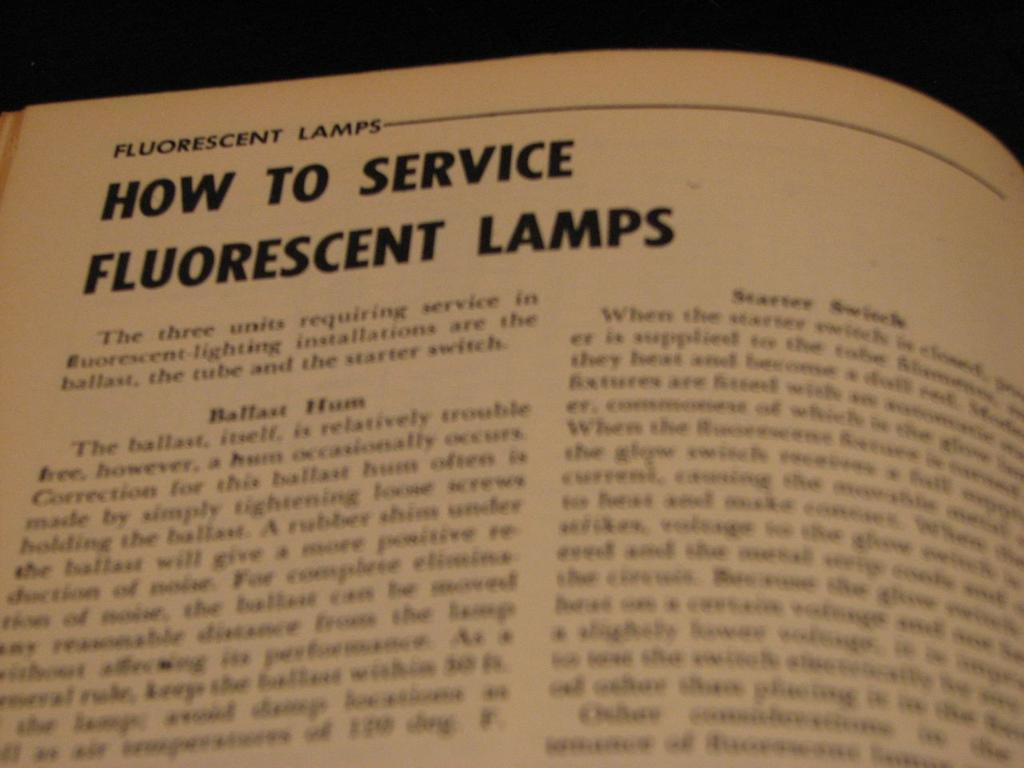<image>
Share a concise interpretation of the image provided. An instructional book has information about how to service fluorescent lamps. 